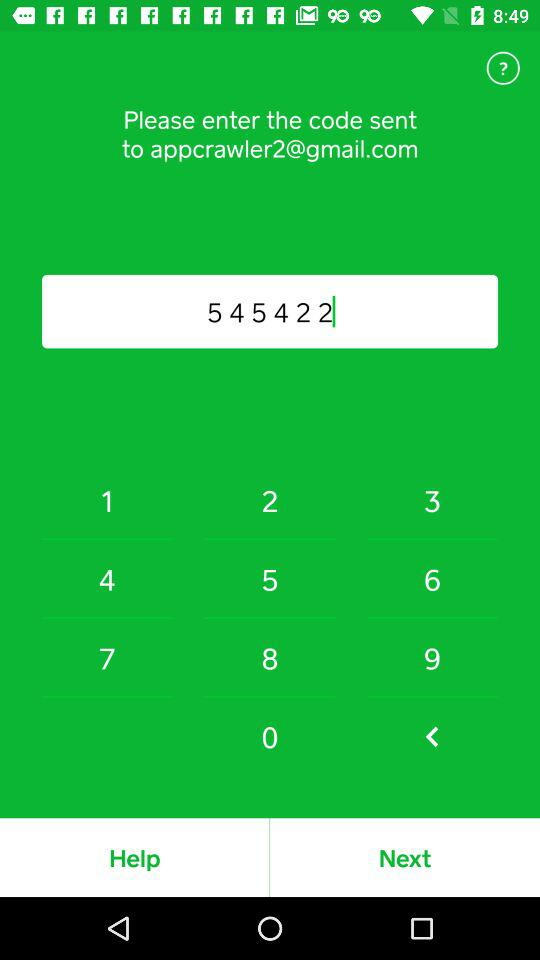What is the email address? The email address is appcrawler2@gmail.com. 